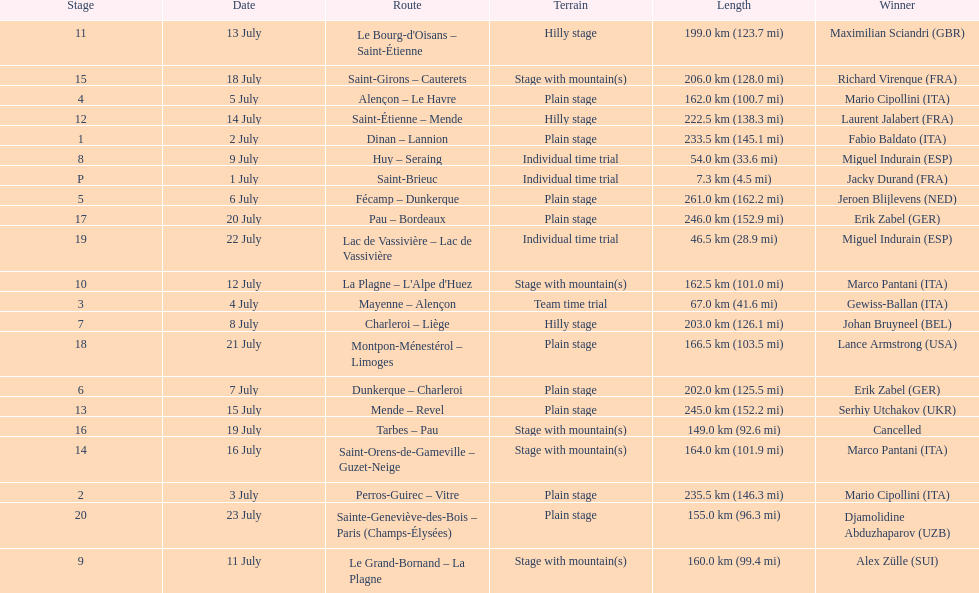Would you be able to parse every entry in this table? {'header': ['Stage', 'Date', 'Route', 'Terrain', 'Length', 'Winner'], 'rows': [['11', '13 July', "Le Bourg-d'Oisans – Saint-Étienne", 'Hilly stage', '199.0\xa0km (123.7\xa0mi)', 'Maximilian Sciandri\xa0(GBR)'], ['15', '18 July', 'Saint-Girons – Cauterets', 'Stage with mountain(s)', '206.0\xa0km (128.0\xa0mi)', 'Richard Virenque\xa0(FRA)'], ['4', '5 July', 'Alençon – Le Havre', 'Plain stage', '162.0\xa0km (100.7\xa0mi)', 'Mario Cipollini\xa0(ITA)'], ['12', '14 July', 'Saint-Étienne – Mende', 'Hilly stage', '222.5\xa0km (138.3\xa0mi)', 'Laurent Jalabert\xa0(FRA)'], ['1', '2 July', 'Dinan – Lannion', 'Plain stage', '233.5\xa0km (145.1\xa0mi)', 'Fabio Baldato\xa0(ITA)'], ['8', '9 July', 'Huy – Seraing', 'Individual time trial', '54.0\xa0km (33.6\xa0mi)', 'Miguel Indurain\xa0(ESP)'], ['P', '1 July', 'Saint-Brieuc', 'Individual time trial', '7.3\xa0km (4.5\xa0mi)', 'Jacky Durand\xa0(FRA)'], ['5', '6 July', 'Fécamp – Dunkerque', 'Plain stage', '261.0\xa0km (162.2\xa0mi)', 'Jeroen Blijlevens\xa0(NED)'], ['17', '20 July', 'Pau – Bordeaux', 'Plain stage', '246.0\xa0km (152.9\xa0mi)', 'Erik Zabel\xa0(GER)'], ['19', '22 July', 'Lac de Vassivière – Lac de Vassivière', 'Individual time trial', '46.5\xa0km (28.9\xa0mi)', 'Miguel Indurain\xa0(ESP)'], ['10', '12 July', "La Plagne – L'Alpe d'Huez", 'Stage with mountain(s)', '162.5\xa0km (101.0\xa0mi)', 'Marco Pantani\xa0(ITA)'], ['3', '4 July', 'Mayenne – Alençon', 'Team time trial', '67.0\xa0km (41.6\xa0mi)', 'Gewiss-Ballan\xa0(ITA)'], ['7', '8 July', 'Charleroi – Liège', 'Hilly stage', '203.0\xa0km (126.1\xa0mi)', 'Johan Bruyneel\xa0(BEL)'], ['18', '21 July', 'Montpon-Ménestérol – Limoges', 'Plain stage', '166.5\xa0km (103.5\xa0mi)', 'Lance Armstrong\xa0(USA)'], ['6', '7 July', 'Dunkerque – Charleroi', 'Plain stage', '202.0\xa0km (125.5\xa0mi)', 'Erik Zabel\xa0(GER)'], ['13', '15 July', 'Mende – Revel', 'Plain stage', '245.0\xa0km (152.2\xa0mi)', 'Serhiy Utchakov\xa0(UKR)'], ['16', '19 July', 'Tarbes – Pau', 'Stage with mountain(s)', '149.0\xa0km (92.6\xa0mi)', 'Cancelled'], ['14', '16 July', 'Saint-Orens-de-Gameville – Guzet-Neige', 'Stage with mountain(s)', '164.0\xa0km (101.9\xa0mi)', 'Marco Pantani\xa0(ITA)'], ['2', '3 July', 'Perros-Guirec – Vitre', 'Plain stage', '235.5\xa0km (146.3\xa0mi)', 'Mario Cipollini\xa0(ITA)'], ['20', '23 July', 'Sainte-Geneviève-des-Bois – Paris (Champs-Élysées)', 'Plain stage', '155.0\xa0km (96.3\xa0mi)', 'Djamolidine Abduzhaparov\xa0(UZB)'], ['9', '11 July', 'Le Grand-Bornand – La Plagne', 'Stage with mountain(s)', '160.0\xa0km (99.4\xa0mi)', 'Alex Zülle\xa0(SUI)']]} Which routes were at least 100 km? Dinan - Lannion, Perros-Guirec - Vitre, Alençon - Le Havre, Fécamp - Dunkerque, Dunkerque - Charleroi, Charleroi - Liège, Le Grand-Bornand - La Plagne, La Plagne - L'Alpe d'Huez, Le Bourg-d'Oisans - Saint-Étienne, Saint-Étienne - Mende, Mende - Revel, Saint-Orens-de-Gameville - Guzet-Neige, Saint-Girons - Cauterets, Tarbes - Pau, Pau - Bordeaux, Montpon-Ménestérol - Limoges, Sainte-Geneviève-des-Bois - Paris (Champs-Élysées). 